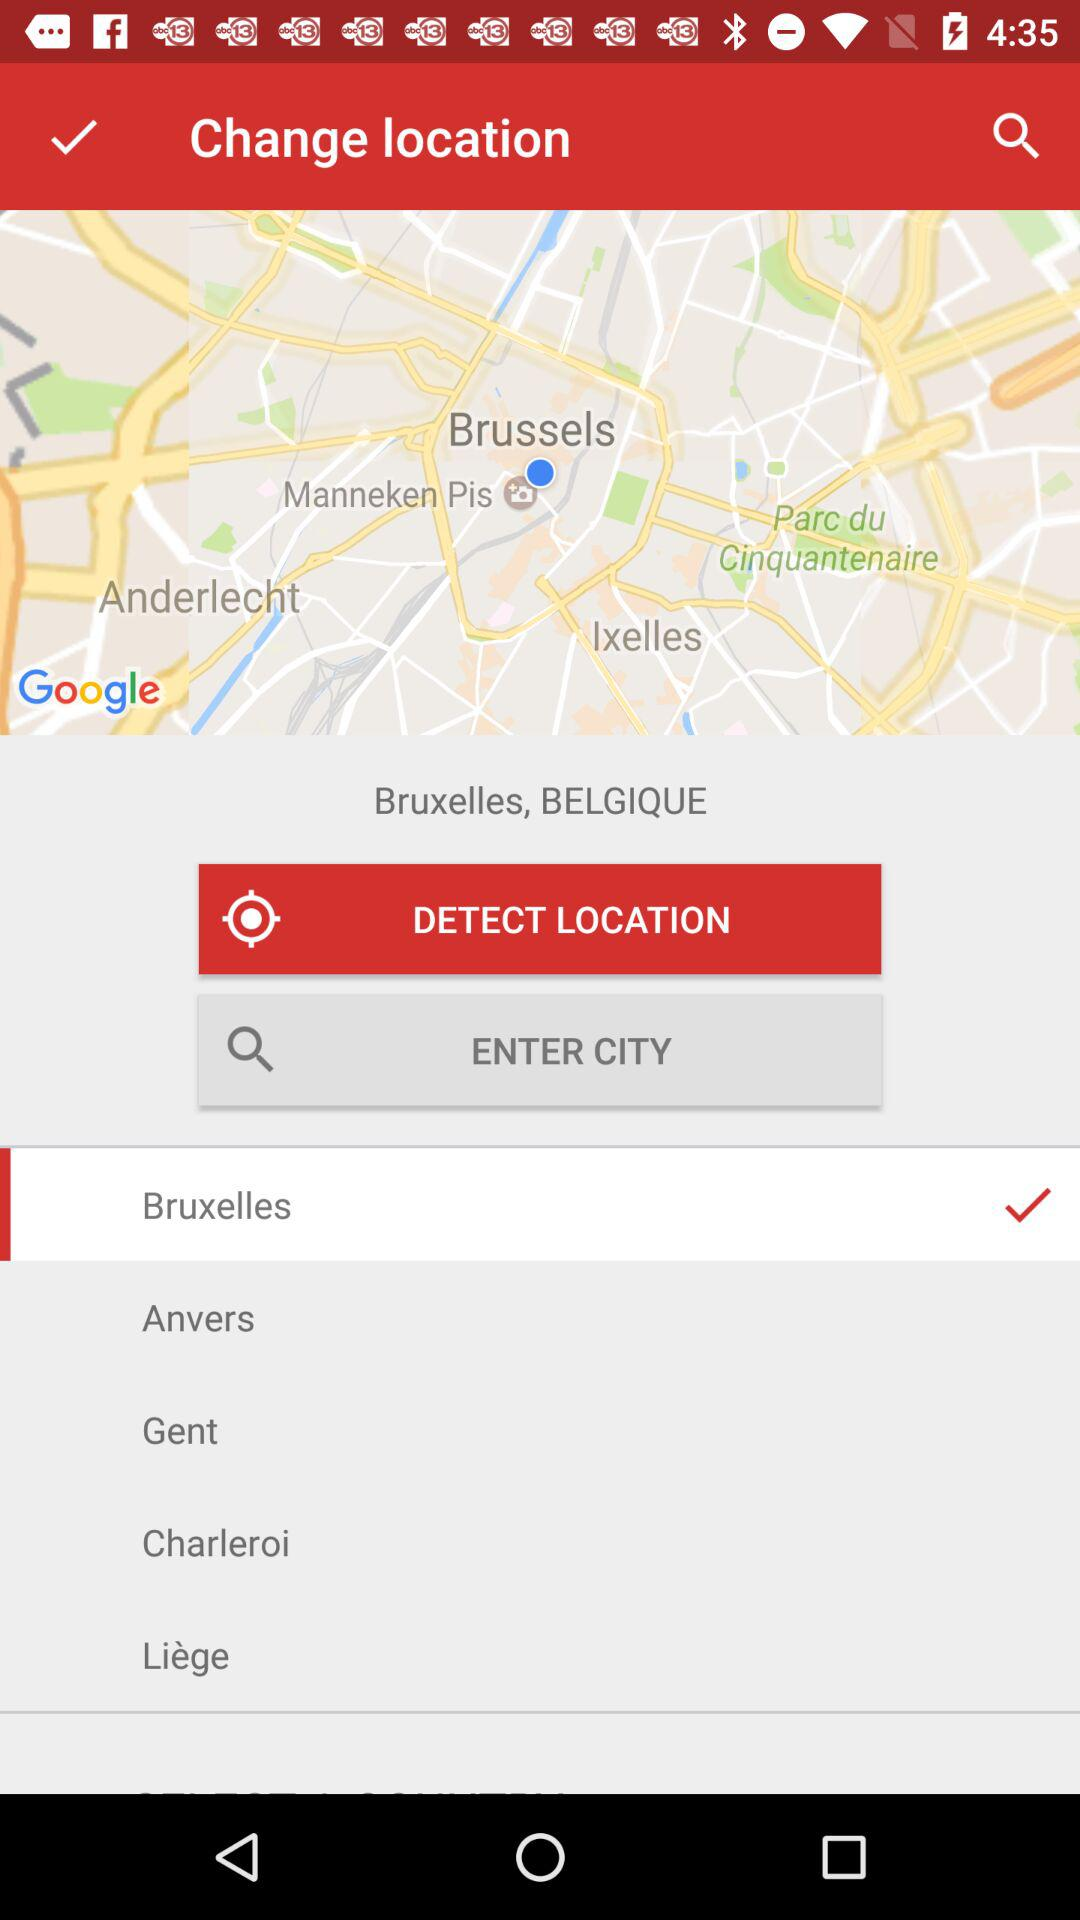Which city has been selected? The selected city is Bruxelles. 